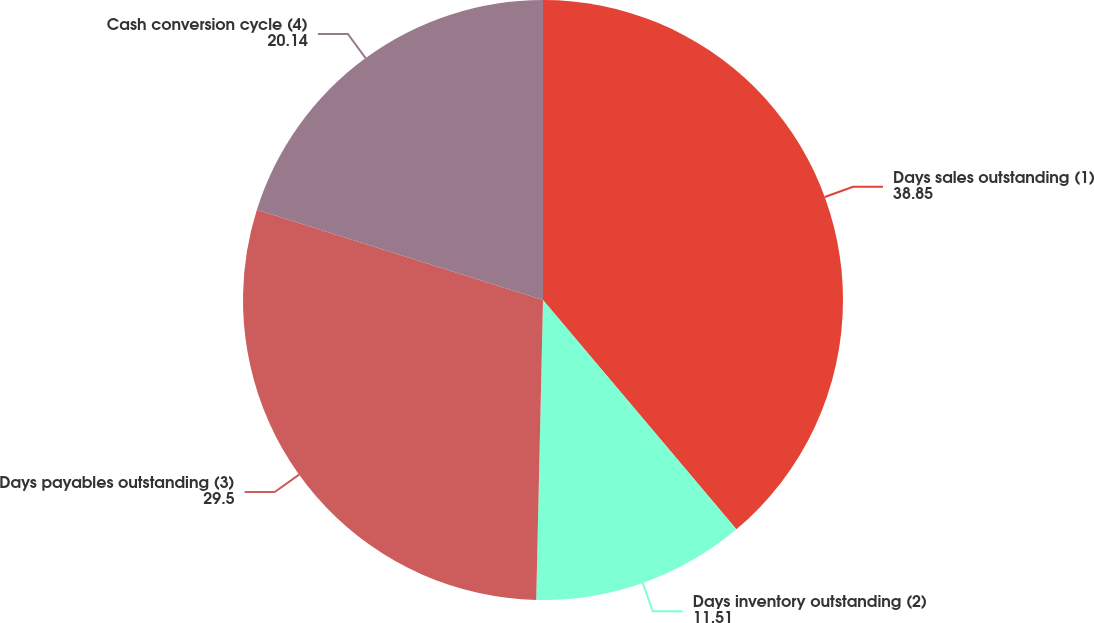Convert chart to OTSL. <chart><loc_0><loc_0><loc_500><loc_500><pie_chart><fcel>Days sales outstanding (1)<fcel>Days inventory outstanding (2)<fcel>Days payables outstanding (3)<fcel>Cash conversion cycle (4)<nl><fcel>38.85%<fcel>11.51%<fcel>29.5%<fcel>20.14%<nl></chart> 